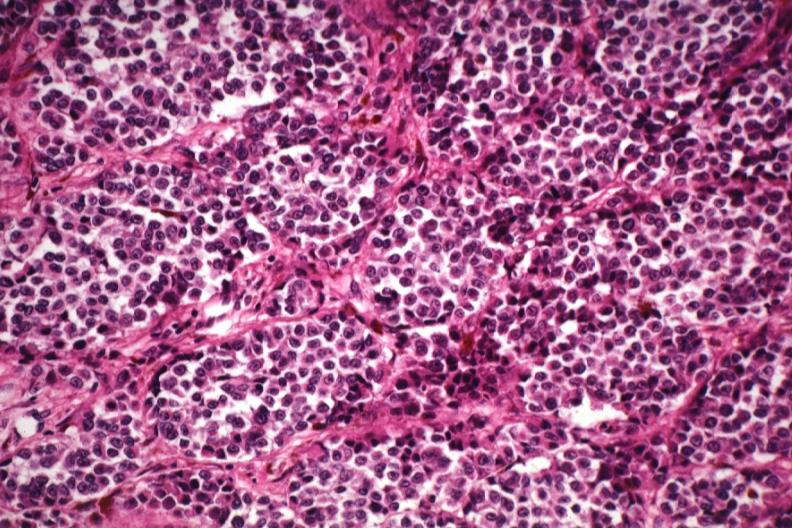what is present?
Answer the question using a single word or phrase. Malignant melanoma 